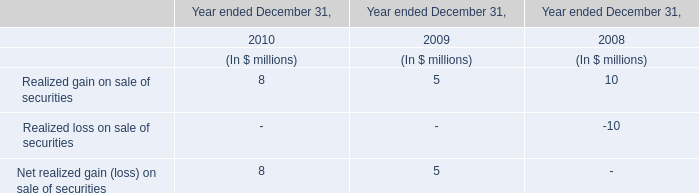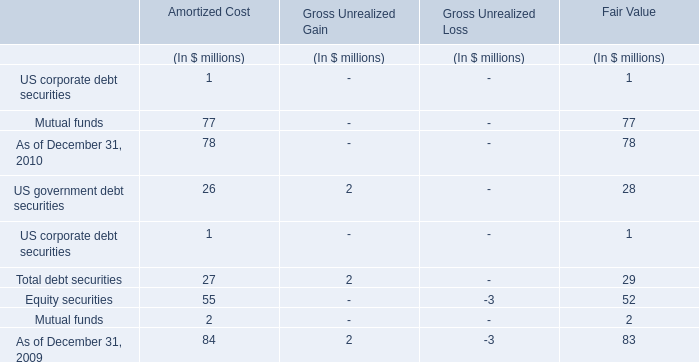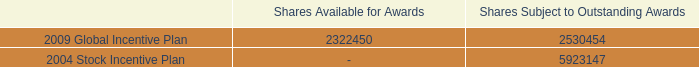what portion of the total shares subject to outstanding awards is under the 2009 global incentive plan? 
Computations: (5923147 / (2530454 + 5923147))
Answer: 0.70067. 